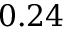<formula> <loc_0><loc_0><loc_500><loc_500>0 . 2 4</formula> 